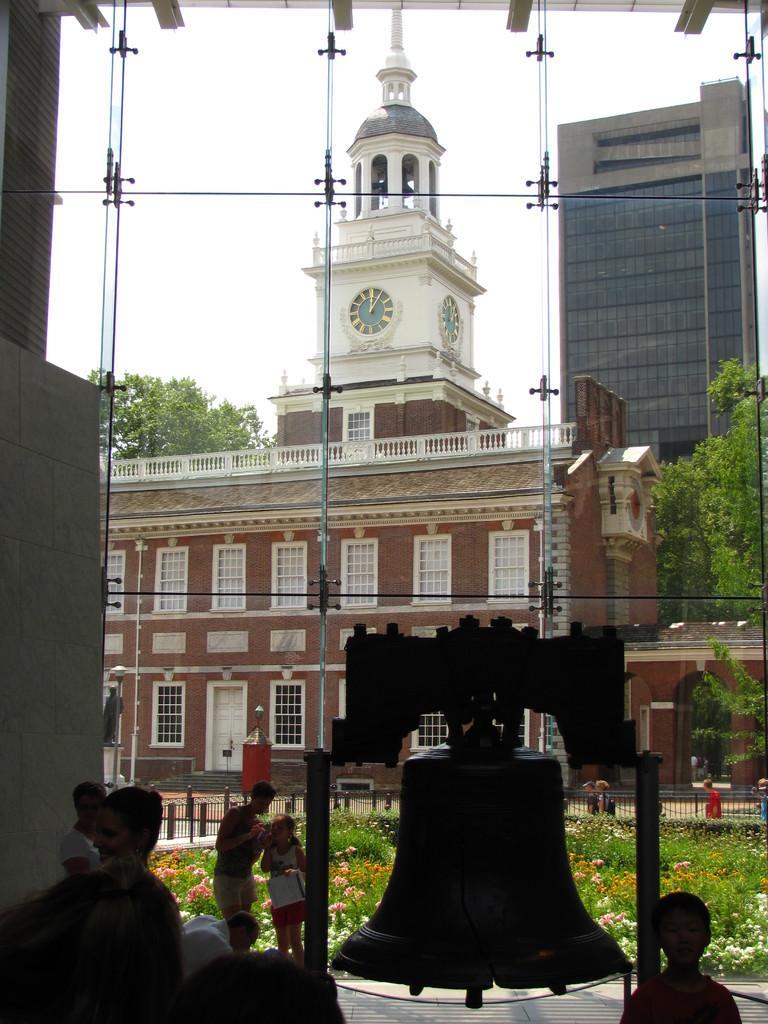Please provide a concise description of this image. In the image there are few people and there is a huge bell behind the glass window and behind that bell there is a beautiful flower garden, in the background there are some buildings. 